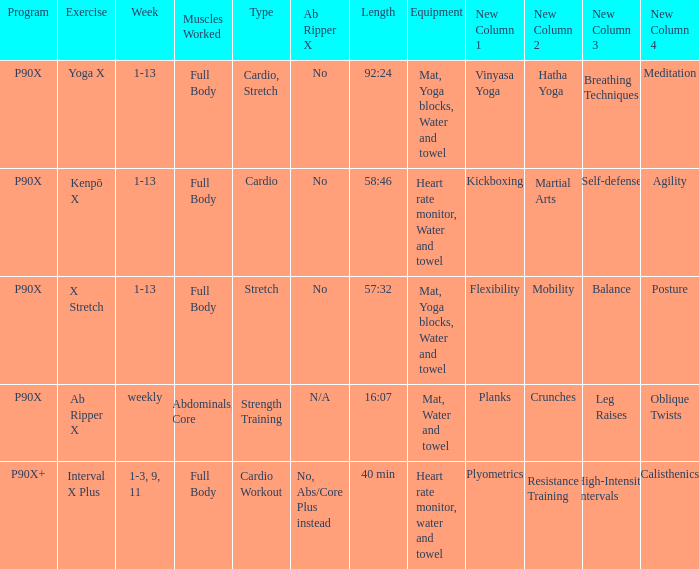Which physical activity requires a heart rate monitor, water, and a towel as equipment? Kenpō X, Interval X Plus. 